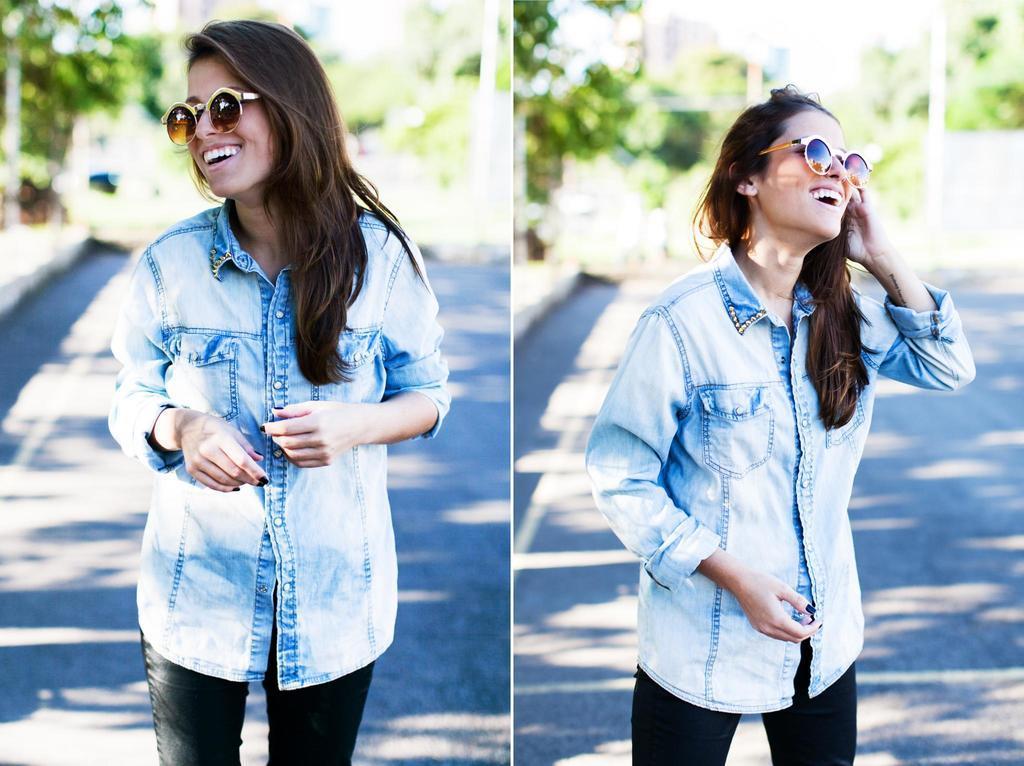Describe this image in one or two sentences. This is a collage. In this picture we can see a woman wearing goggles and standing on the path. She is smiling. Background is blurry. 